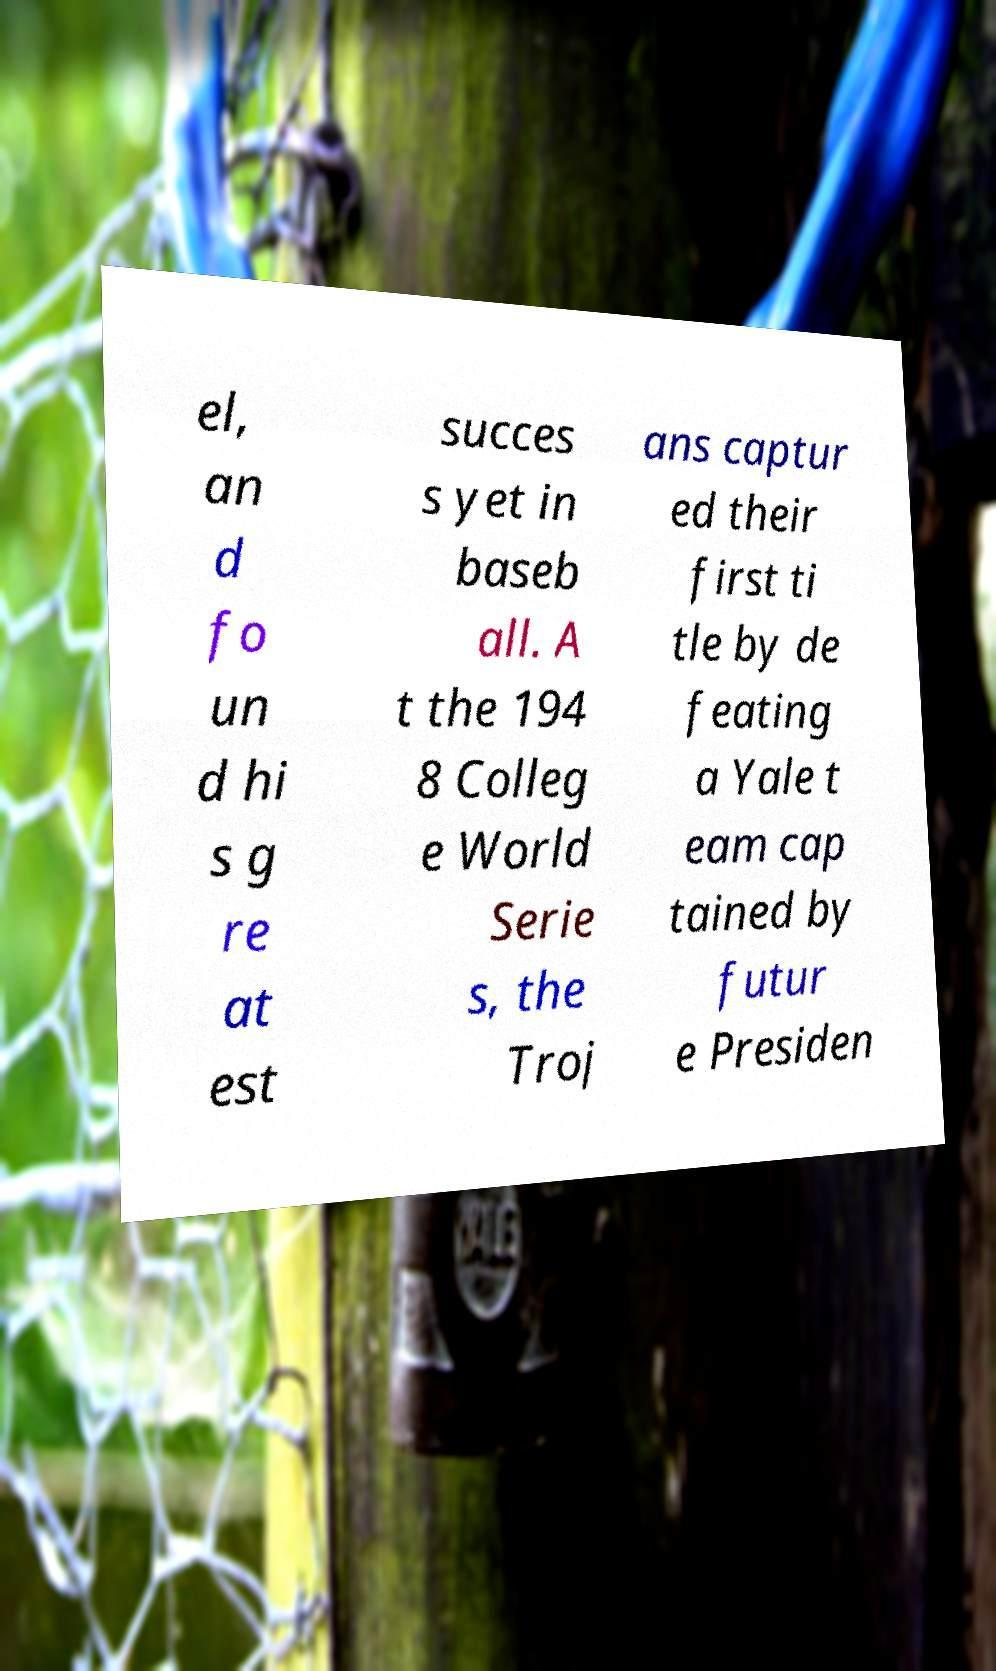What messages or text are displayed in this image? I need them in a readable, typed format. el, an d fo un d hi s g re at est succes s yet in baseb all. A t the 194 8 Colleg e World Serie s, the Troj ans captur ed their first ti tle by de feating a Yale t eam cap tained by futur e Presiden 